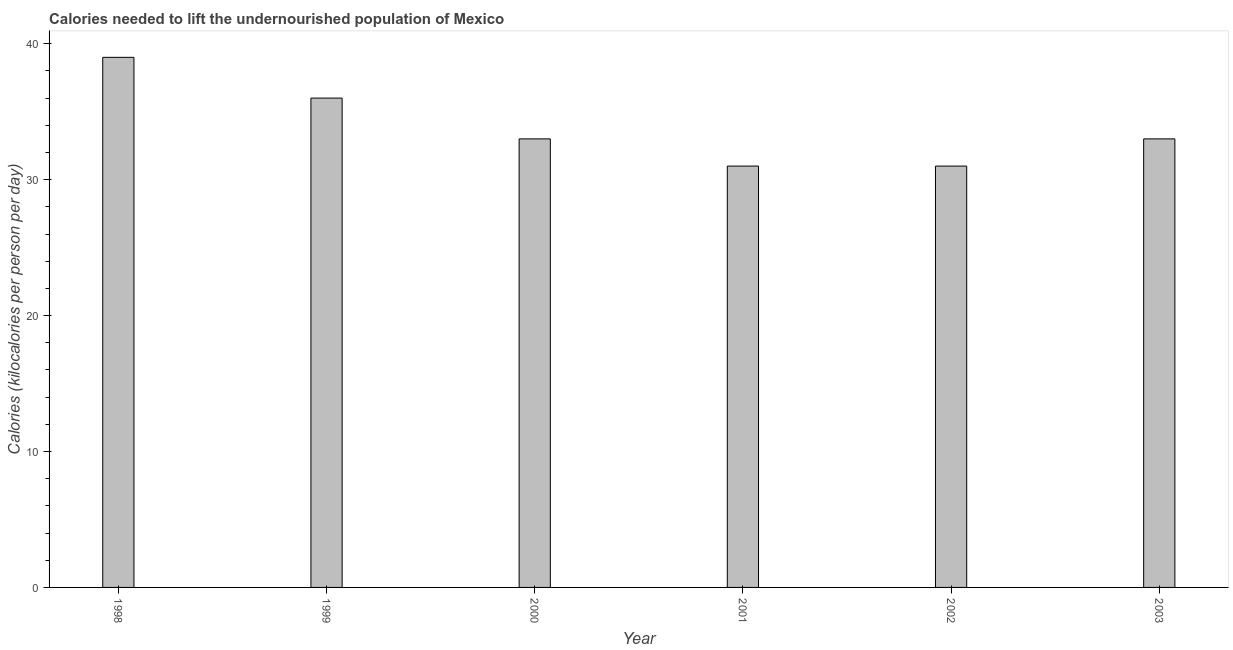Does the graph contain any zero values?
Your answer should be very brief. No. What is the title of the graph?
Make the answer very short. Calories needed to lift the undernourished population of Mexico. What is the label or title of the X-axis?
Your response must be concise. Year. What is the label or title of the Y-axis?
Give a very brief answer. Calories (kilocalories per person per day). What is the depth of food deficit in 2000?
Keep it short and to the point. 33. Across all years, what is the maximum depth of food deficit?
Offer a terse response. 39. In which year was the depth of food deficit minimum?
Give a very brief answer. 2001. What is the sum of the depth of food deficit?
Give a very brief answer. 203. Do a majority of the years between 2003 and 2001 (inclusive) have depth of food deficit greater than 20 kilocalories?
Offer a terse response. Yes. Is the depth of food deficit in 1998 less than that in 2001?
Provide a short and direct response. No. Is the difference between the depth of food deficit in 1998 and 2002 greater than the difference between any two years?
Provide a short and direct response. Yes. Are all the bars in the graph horizontal?
Your answer should be very brief. No. How many years are there in the graph?
Your response must be concise. 6. Are the values on the major ticks of Y-axis written in scientific E-notation?
Give a very brief answer. No. What is the Calories (kilocalories per person per day) in 1999?
Provide a succinct answer. 36. What is the difference between the Calories (kilocalories per person per day) in 1998 and 1999?
Ensure brevity in your answer.  3. What is the difference between the Calories (kilocalories per person per day) in 1998 and 2000?
Your answer should be compact. 6. What is the difference between the Calories (kilocalories per person per day) in 1999 and 2000?
Your answer should be very brief. 3. What is the difference between the Calories (kilocalories per person per day) in 2002 and 2003?
Your response must be concise. -2. What is the ratio of the Calories (kilocalories per person per day) in 1998 to that in 1999?
Your answer should be very brief. 1.08. What is the ratio of the Calories (kilocalories per person per day) in 1998 to that in 2000?
Your answer should be compact. 1.18. What is the ratio of the Calories (kilocalories per person per day) in 1998 to that in 2001?
Offer a terse response. 1.26. What is the ratio of the Calories (kilocalories per person per day) in 1998 to that in 2002?
Your response must be concise. 1.26. What is the ratio of the Calories (kilocalories per person per day) in 1998 to that in 2003?
Make the answer very short. 1.18. What is the ratio of the Calories (kilocalories per person per day) in 1999 to that in 2000?
Provide a short and direct response. 1.09. What is the ratio of the Calories (kilocalories per person per day) in 1999 to that in 2001?
Your answer should be very brief. 1.16. What is the ratio of the Calories (kilocalories per person per day) in 1999 to that in 2002?
Provide a succinct answer. 1.16. What is the ratio of the Calories (kilocalories per person per day) in 1999 to that in 2003?
Give a very brief answer. 1.09. What is the ratio of the Calories (kilocalories per person per day) in 2000 to that in 2001?
Make the answer very short. 1.06. What is the ratio of the Calories (kilocalories per person per day) in 2000 to that in 2002?
Offer a terse response. 1.06. What is the ratio of the Calories (kilocalories per person per day) in 2000 to that in 2003?
Keep it short and to the point. 1. What is the ratio of the Calories (kilocalories per person per day) in 2001 to that in 2002?
Provide a succinct answer. 1. What is the ratio of the Calories (kilocalories per person per day) in 2001 to that in 2003?
Keep it short and to the point. 0.94. What is the ratio of the Calories (kilocalories per person per day) in 2002 to that in 2003?
Your answer should be very brief. 0.94. 